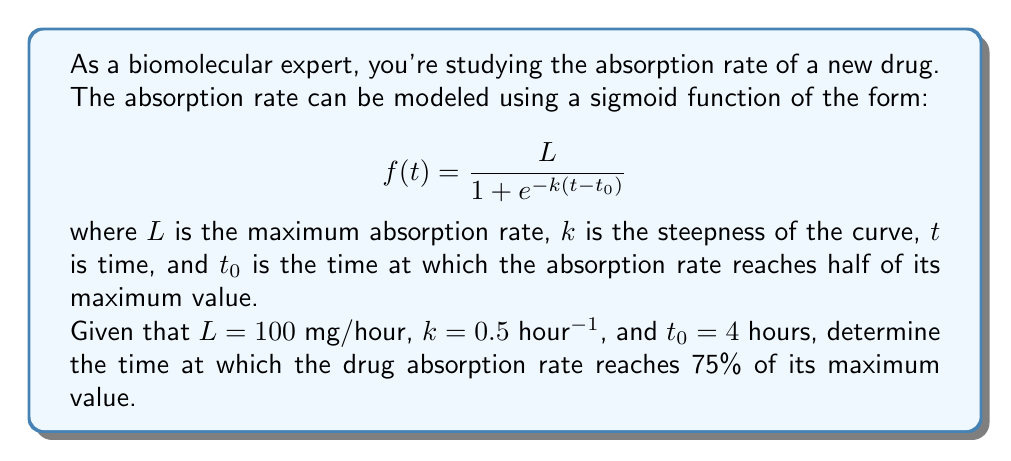What is the answer to this math problem? To solve this problem, we need to follow these steps:

1) The sigmoid function given is:

   $$f(t) = \frac{100}{1 + e^{-0.5(t-4)}}$$

2) We want to find $t$ when $f(t) = 75$ mg/hour (75% of the maximum value of 100 mg/hour).

3) Set up the equation:

   $$75 = \frac{100}{1 + e^{-0.5(t-4)}}$$

4) Multiply both sides by the denominator:

   $$75(1 + e^{-0.5(t-4)}) = 100$$

5) Distribute on the left side:

   $$75 + 75e^{-0.5(t-4)} = 100$$

6) Subtract 75 from both sides:

   $$75e^{-0.5(t-4)} = 25$$

7) Divide both sides by 75:

   $$e^{-0.5(t-4)} = \frac{1}{3}$$

8) Take the natural logarithm of both sides:

   $$-0.5(t-4) = \ln(\frac{1}{3})$$

9) Multiply both sides by -2:

   $$(t-4) = -2\ln(\frac{1}{3})$$

10) Add 4 to both sides:

    $$t = 4 - 2\ln(\frac{1}{3})$$

11) Simplify:

    $$t = 4 + 2\ln(3) \approx 6.20$$

Therefore, the drug absorption rate reaches 75% of its maximum value approximately 6.20 hours after administration.
Answer: $t = 4 + 2\ln(3) \approx 6.20$ hours 